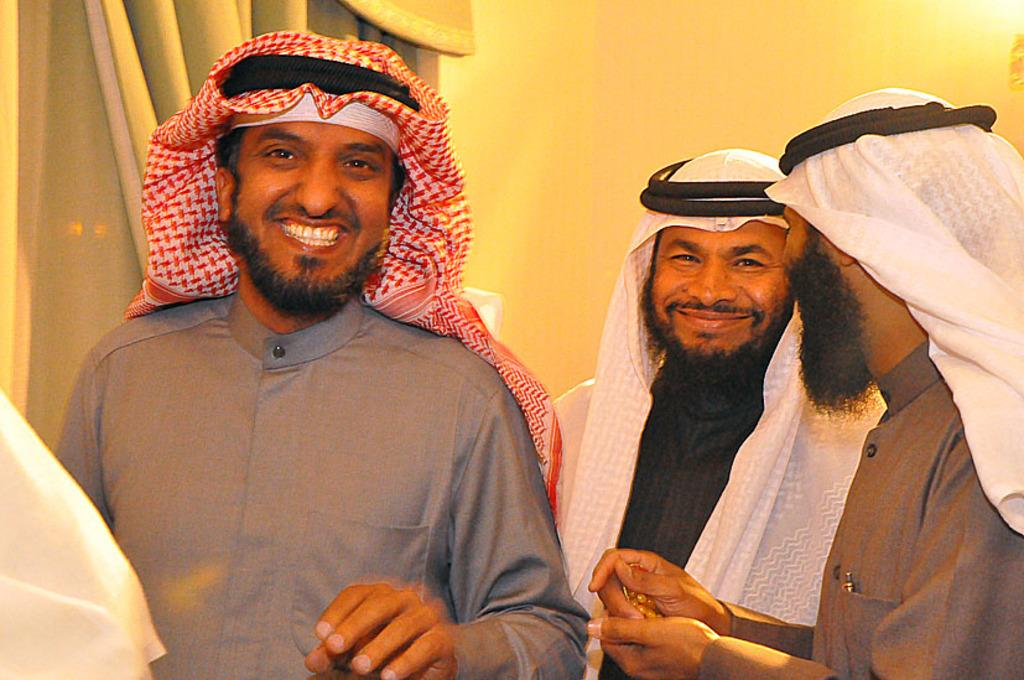How many people are in the image? There are three people in the image. What is the ethnicity of the people in the image? The people are Arab. What are the people in the image doing? The people are standing and talking with each other, and they are laughing. What can be seen on the left side of the background in the image? There is a curtain on the left side of the background. What can be seen on the right side of the background in the image? There is a wall on the right side of the background. What type of sack can be seen on the top of the wall in the image? There is no sack present on the top of the wall in the image. What color are the berries that the people are eating in the image? There are no berries present in the image; the people are laughing and talking with each other. 